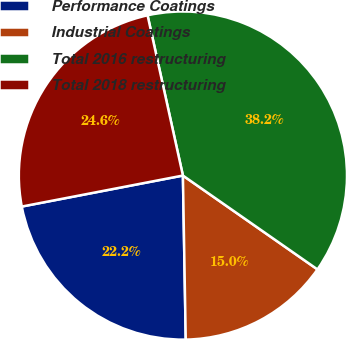Convert chart. <chart><loc_0><loc_0><loc_500><loc_500><pie_chart><fcel>Performance Coatings<fcel>Industrial Coatings<fcel>Total 2016 restructuring<fcel>Total 2018 restructuring<nl><fcel>22.25%<fcel>15.03%<fcel>38.15%<fcel>24.57%<nl></chart> 